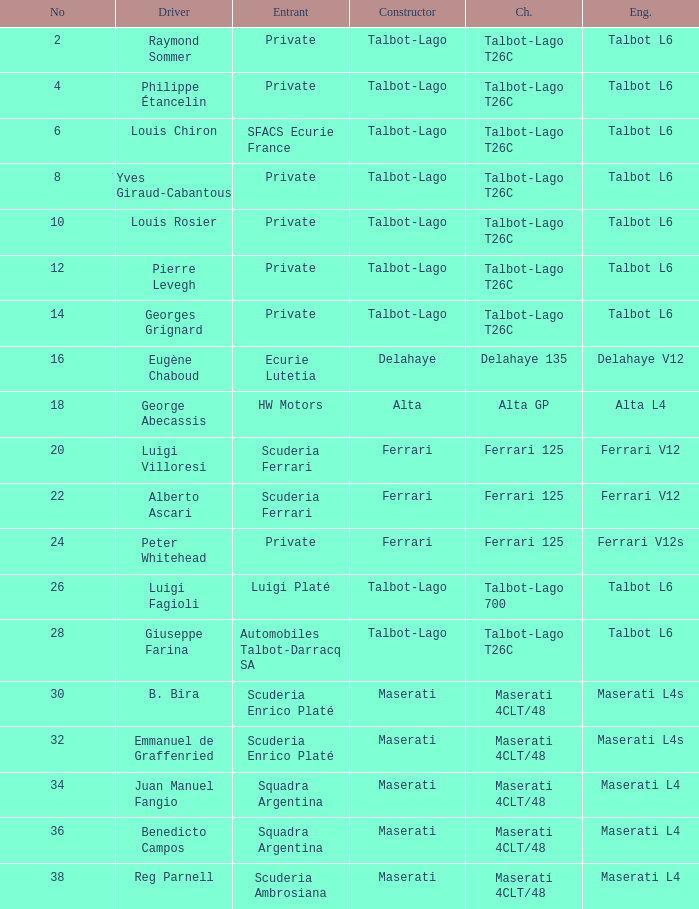Name the constructor for b. bira Maserati. 